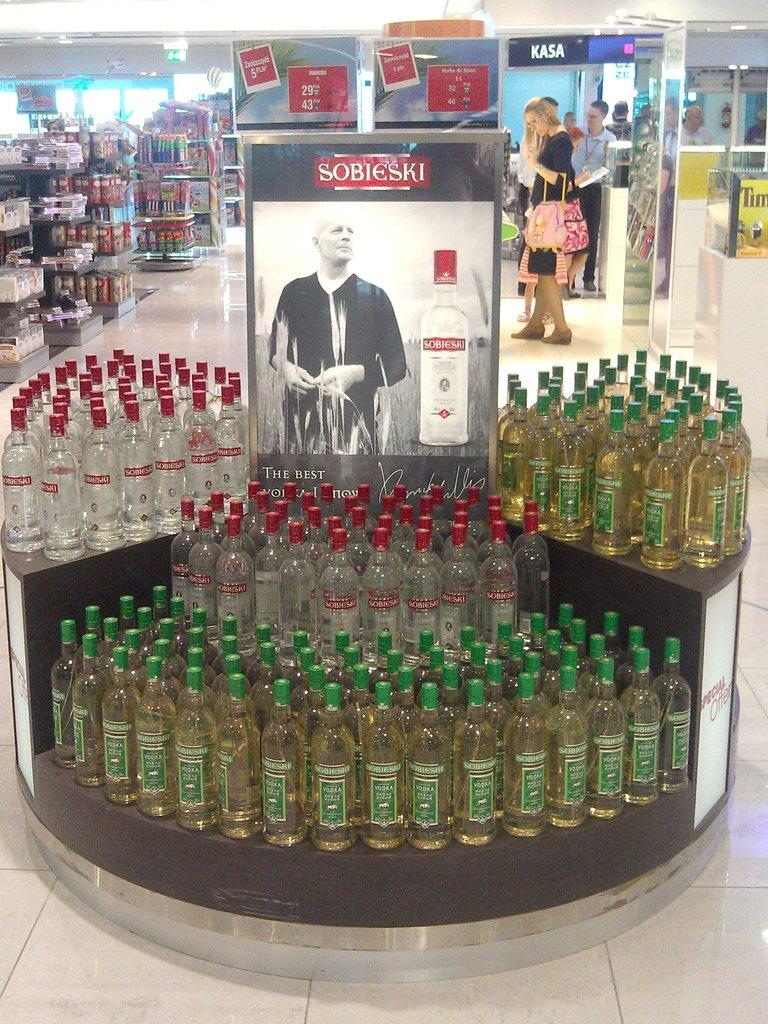<image>
Provide a brief description of the given image. Display showing many alcohol bottles including Sobieski on it. 